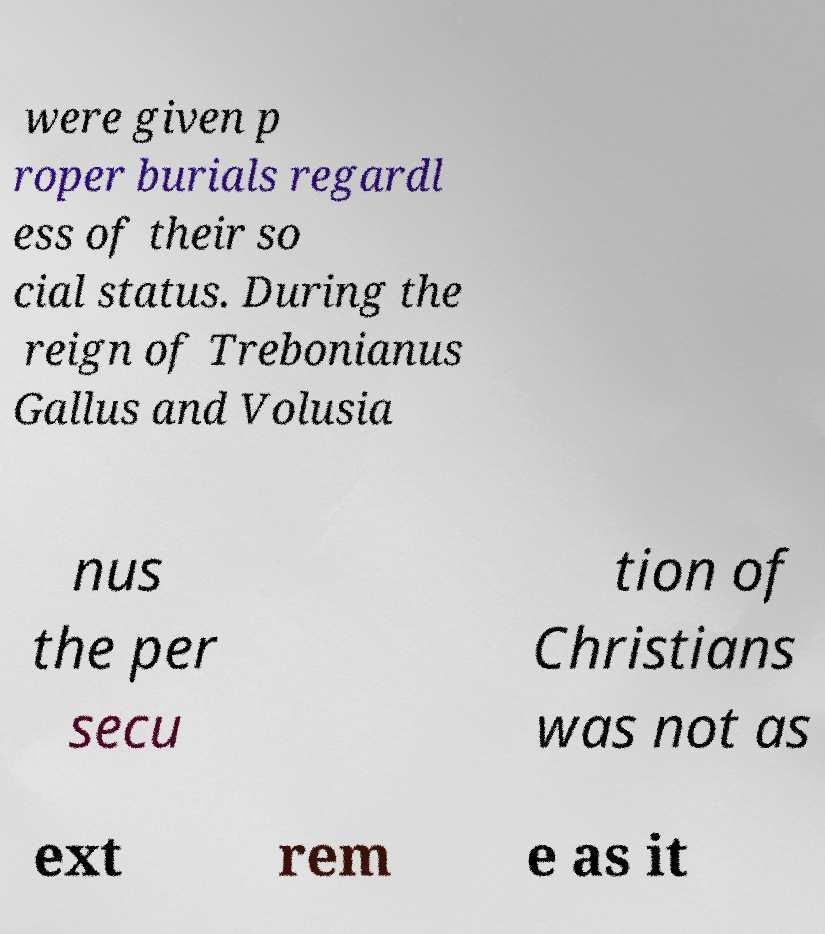What messages or text are displayed in this image? I need them in a readable, typed format. were given p roper burials regardl ess of their so cial status. During the reign of Trebonianus Gallus and Volusia nus the per secu tion of Christians was not as ext rem e as it 